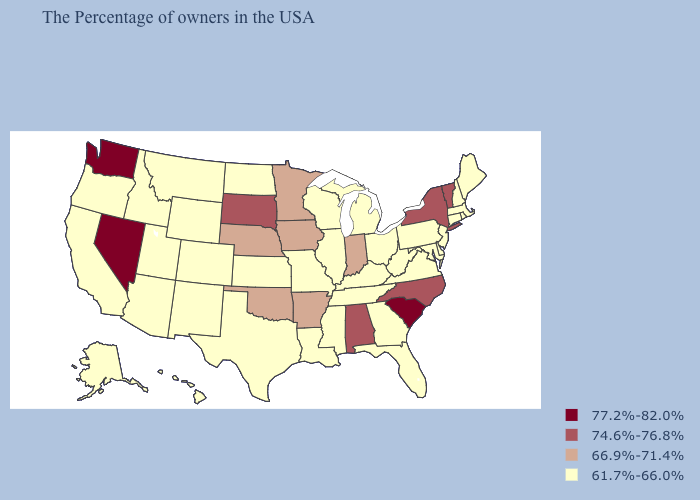Name the states that have a value in the range 74.6%-76.8%?
Give a very brief answer. Vermont, New York, North Carolina, Alabama, South Dakota. What is the highest value in states that border Maine?
Short answer required. 61.7%-66.0%. Which states have the highest value in the USA?
Write a very short answer. South Carolina, Nevada, Washington. Among the states that border Michigan , does Wisconsin have the highest value?
Short answer required. No. What is the highest value in the USA?
Short answer required. 77.2%-82.0%. What is the highest value in the USA?
Write a very short answer. 77.2%-82.0%. What is the value of Texas?
Be succinct. 61.7%-66.0%. Among the states that border Louisiana , which have the highest value?
Write a very short answer. Arkansas. Does California have the lowest value in the USA?
Answer briefly. Yes. Does Mississippi have a higher value than Alabama?
Write a very short answer. No. What is the highest value in states that border Pennsylvania?
Write a very short answer. 74.6%-76.8%. Name the states that have a value in the range 61.7%-66.0%?
Answer briefly. Maine, Massachusetts, Rhode Island, New Hampshire, Connecticut, New Jersey, Delaware, Maryland, Pennsylvania, Virginia, West Virginia, Ohio, Florida, Georgia, Michigan, Kentucky, Tennessee, Wisconsin, Illinois, Mississippi, Louisiana, Missouri, Kansas, Texas, North Dakota, Wyoming, Colorado, New Mexico, Utah, Montana, Arizona, Idaho, California, Oregon, Alaska, Hawaii. Does Nevada have the lowest value in the USA?
Keep it brief. No. Name the states that have a value in the range 74.6%-76.8%?
Answer briefly. Vermont, New York, North Carolina, Alabama, South Dakota. Does Montana have a lower value than Delaware?
Short answer required. No. 